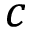Convert formula to latex. <formula><loc_0><loc_0><loc_500><loc_500>c</formula> 